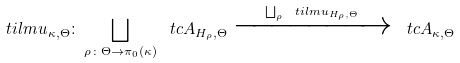Convert formula to latex. <formula><loc_0><loc_0><loc_500><loc_500>\ t i l m u _ { \kappa , \Theta } \colon \bigsqcup _ { \rho \colon \Theta \to \pi _ { 0 } ( \kappa ) } \ t c A _ { H _ { \rho } , \Theta } \xrightarrow { \bigsqcup _ { \rho } \ t i l m u _ { H _ { \rho } , \Theta } } \ t c A _ { \kappa , \Theta }</formula> 